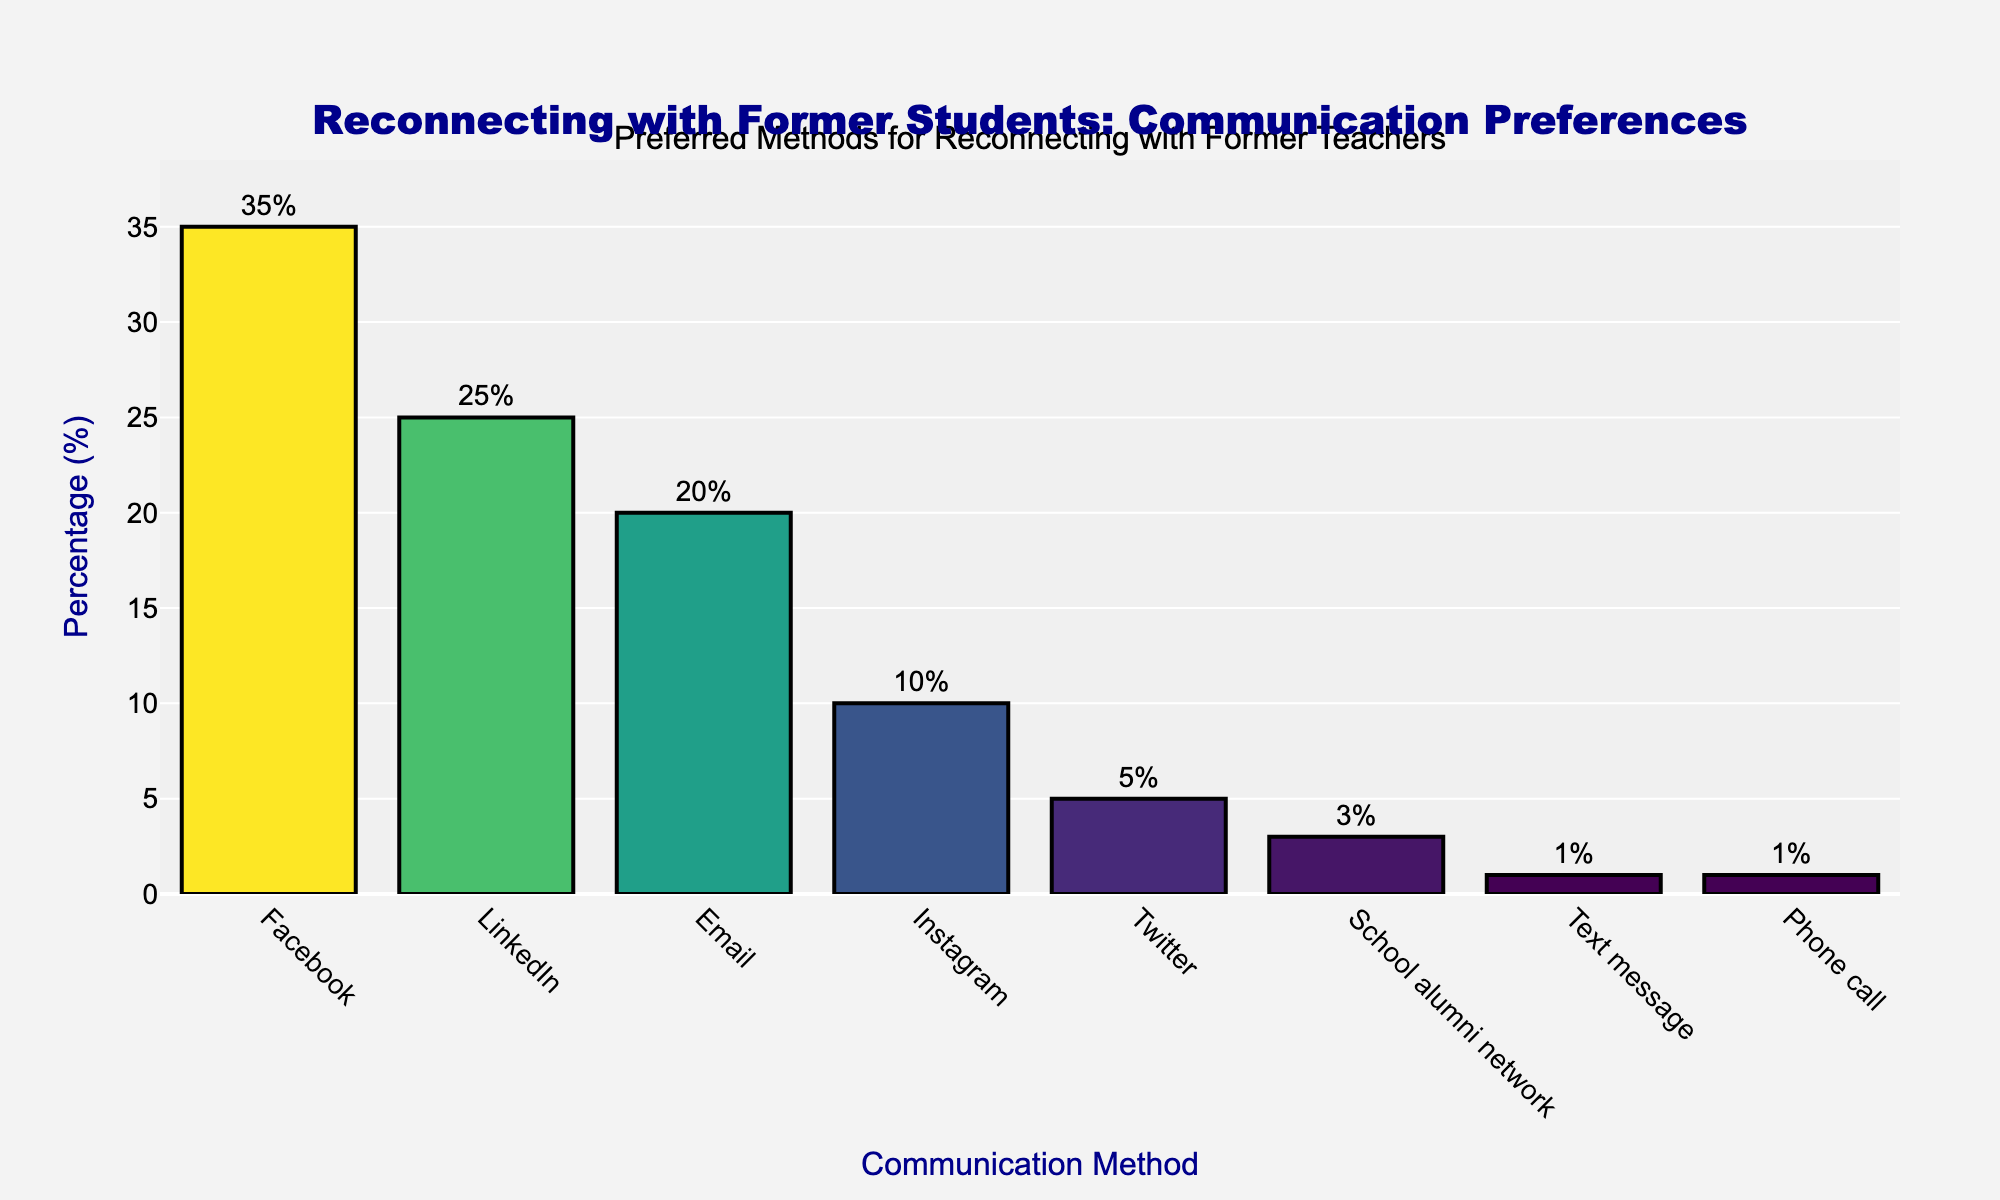Which communication method is the most preferred? The bar representing Facebook is the tallest, indicating it has the highest percentage of 35%. Therefore, Facebook is the most preferred method.
Answer: Facebook Which communication method is the least preferred? The bars representing Text message and Phone call are the shortest, both indicating a percentage of 1%. Therefore, they are the least preferred methods.
Answer: Text message and Phone call What is the combined percentage of people preferring LinkedIn and Email? The percentages for LinkedIn and Email are 25% and 20%, respectively. Adding these together gives 25% + 20% = 45%.
Answer: 45% How much more popular is Facebook compared to Instagram? The percentage for Facebook is 35% and for Instagram is 10%. Subtracting these gives 35% - 10% = 25%. So, Facebook is 25% more popular than Instagram.
Answer: 25% Which methods have a preference percentage lower than 10%? The bars representing School alumni network (3%), Text message (1%), and Phone call (1%) are all below the 10% marker.
Answer: School alumni network, Text message, Phone call What is the total percentage of all communication methods combined? The sum of all percentages is 35% + 25% + 20% + 10% + 5% + 3% + 1% + 1% = 100%.
Answer: 100% Among the social media platforms (Facebook, LinkedIn, Instagram, Twitter), which one has the lowest preference percentage? Among the social media platforms, the bar representing Twitter is the shortest with a percentage of 5%.
Answer: Twitter How does the percentage preferring Email compare to those preferring Twitter and Instagram combined? The percentage for Email is 20%. The combined percentage for Twitter and Instagram is 5% + 10% = 15%. Email's percentage is higher by 20% - 15% = 5%.
Answer: Email is higher by 5% What is the average preference percentage of all the listed communication methods? There are 8 communication methods. The sum of all percentages is 100%. The average is calculated by dividing the total by the number of methods, 100% / 8 = 12.5%.
Answer: 12.5% Which methods have a percentage higher than the average preference percentage? The average preference percentage is 12.5%. The methods with percentages higher than this are Facebook (35%), LinkedIn (25%), and Email (20%).
Answer: Facebook, LinkedIn, and Email 